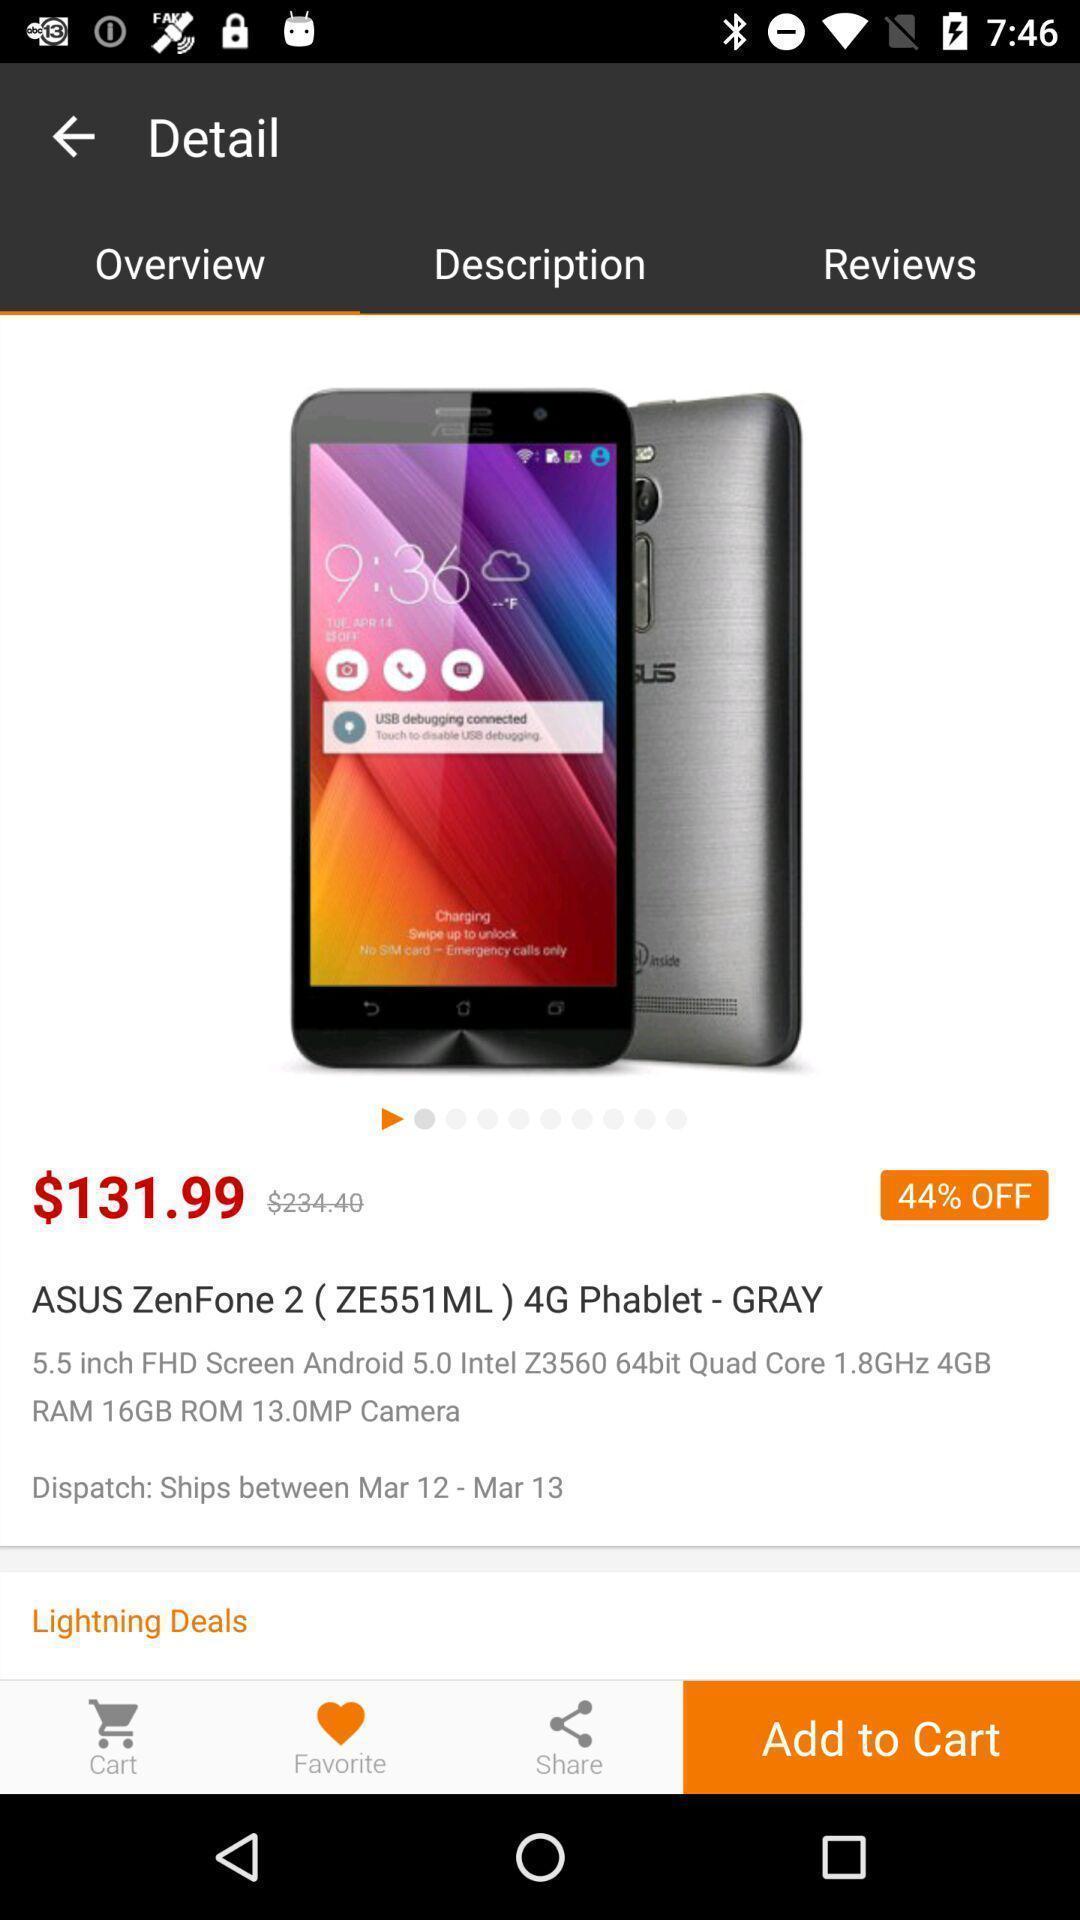Provide a textual representation of this image. Page displaying the details about a mobile. 